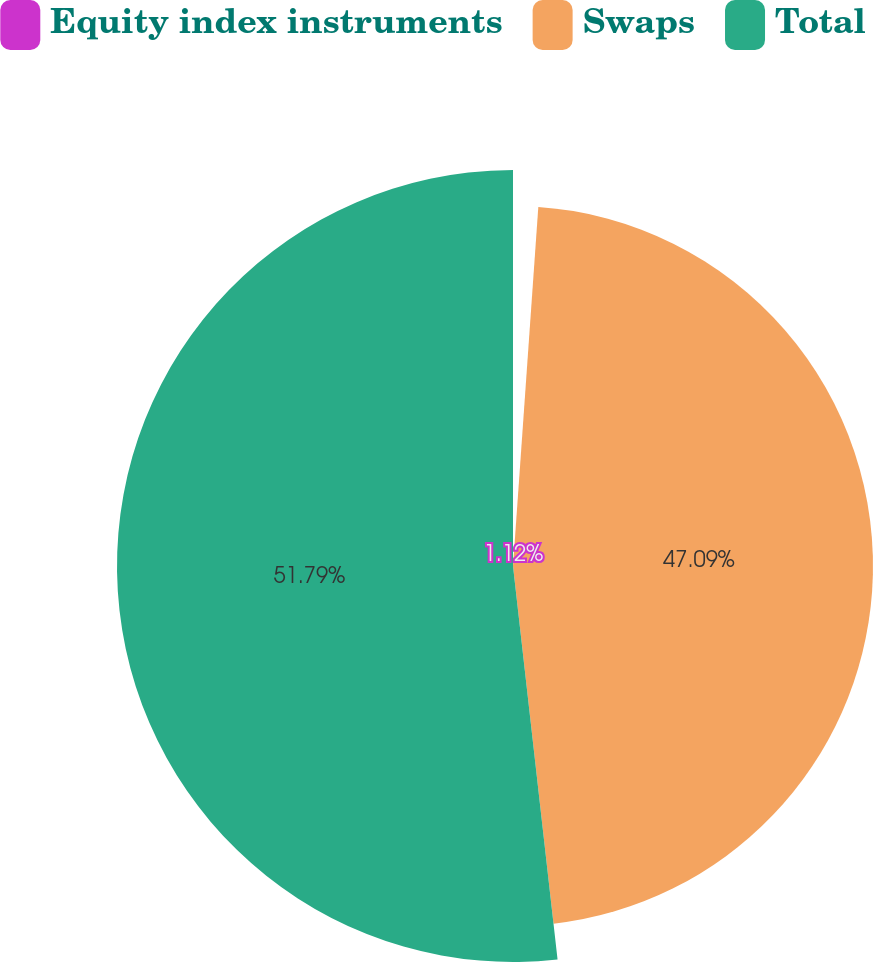Convert chart to OTSL. <chart><loc_0><loc_0><loc_500><loc_500><pie_chart><fcel>Equity index instruments<fcel>Swaps<fcel>Total<nl><fcel>1.12%<fcel>47.09%<fcel>51.8%<nl></chart> 